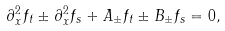<formula> <loc_0><loc_0><loc_500><loc_500>\partial _ { x } ^ { 2 } f _ { t } \pm \partial _ { x } ^ { 2 } f _ { s } + A _ { \pm } f _ { t } \pm B _ { \pm } f _ { s } = 0 ,</formula> 